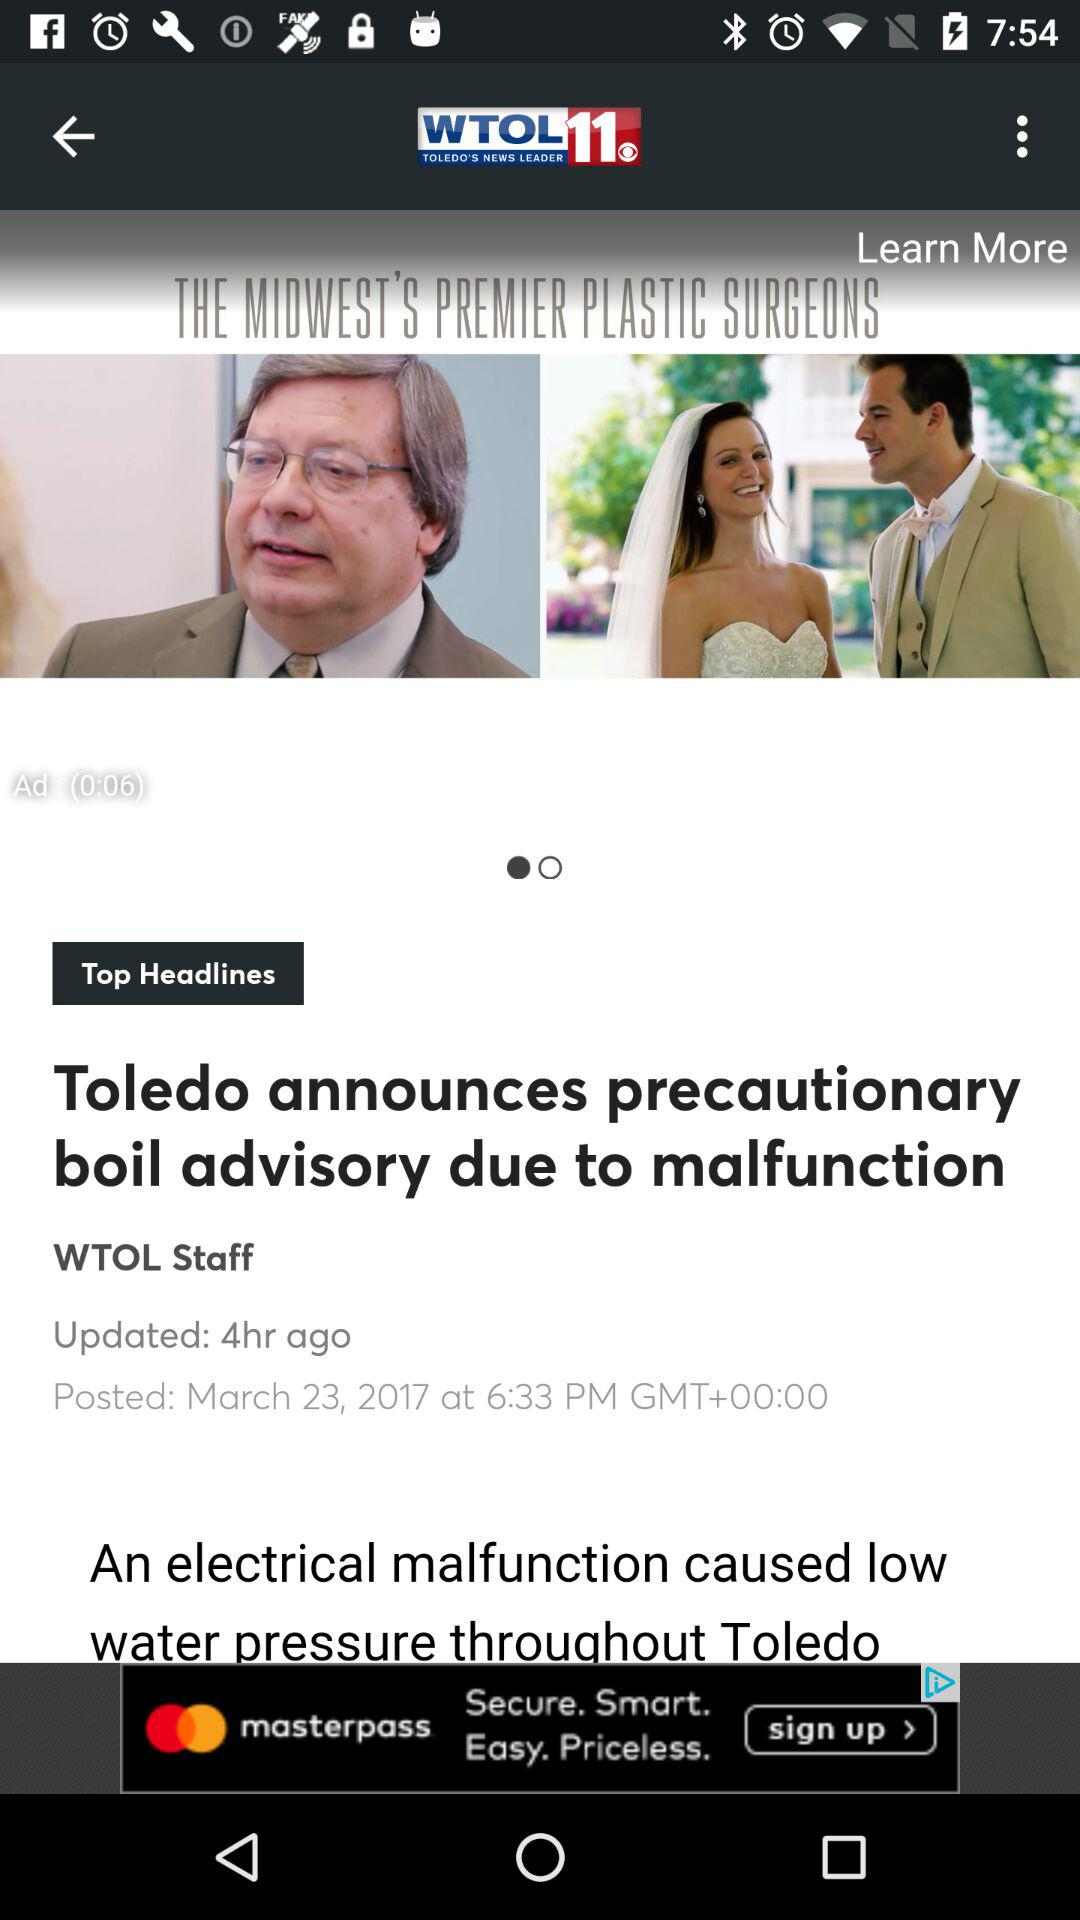At what time was the news "Toledo announces precautionary boil advisory due to malfunction" posted? The news "Toledo announces precautionary boil advisory due to malfunction" was posted at 6:33 PM. 